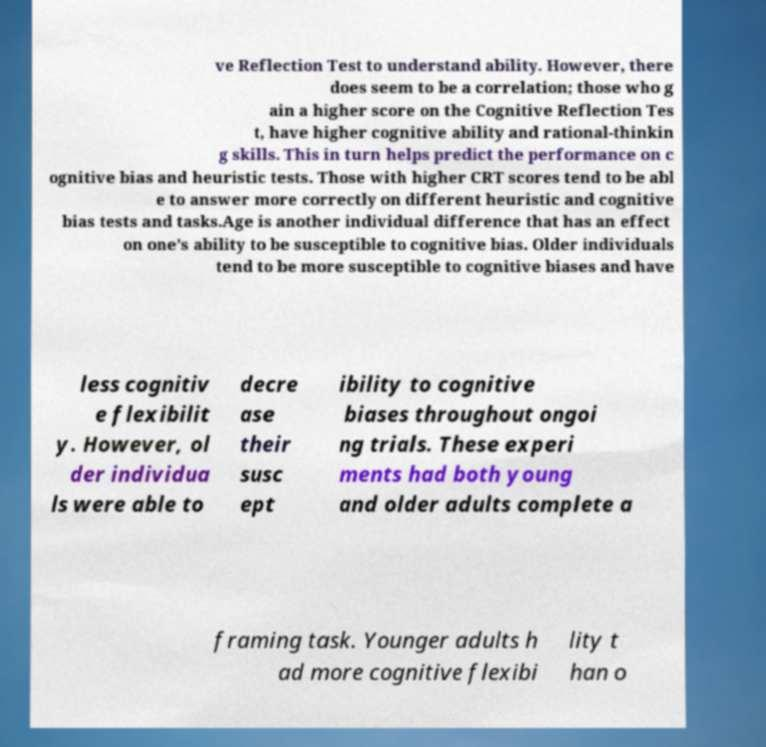Can you accurately transcribe the text from the provided image for me? ve Reflection Test to understand ability. However, there does seem to be a correlation; those who g ain a higher score on the Cognitive Reflection Tes t, have higher cognitive ability and rational-thinkin g skills. This in turn helps predict the performance on c ognitive bias and heuristic tests. Those with higher CRT scores tend to be abl e to answer more correctly on different heuristic and cognitive bias tests and tasks.Age is another individual difference that has an effect on one’s ability to be susceptible to cognitive bias. Older individuals tend to be more susceptible to cognitive biases and have less cognitiv e flexibilit y. However, ol der individua ls were able to decre ase their susc ept ibility to cognitive biases throughout ongoi ng trials. These experi ments had both young and older adults complete a framing task. Younger adults h ad more cognitive flexibi lity t han o 